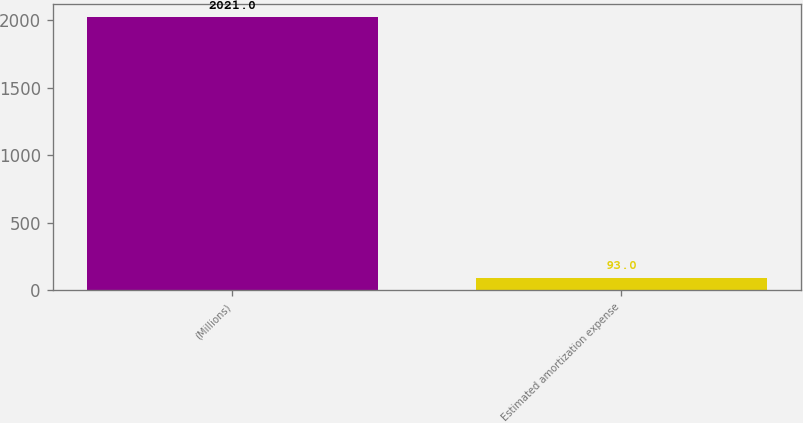Convert chart to OTSL. <chart><loc_0><loc_0><loc_500><loc_500><bar_chart><fcel>(Millions)<fcel>Estimated amortization expense<nl><fcel>2021<fcel>93<nl></chart> 